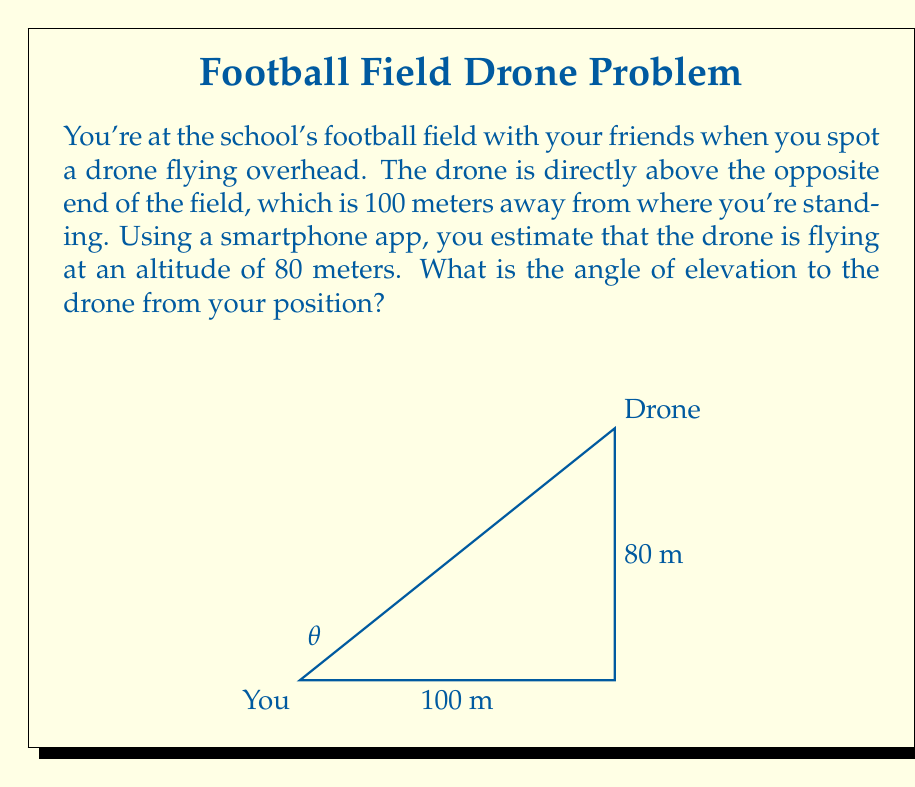Give your solution to this math problem. Let's approach this step-by-step using trigonometry:

1) We can identify this as a right triangle problem. The angle of elevation is the angle between the horizontal line of sight and the line of sight to the drone.

2) We know:
   - The adjacent side (distance along the ground) = 100 meters
   - The opposite side (height of the drone) = 80 meters

3) To find the angle, we can use the tangent function:

   $$ \tan(\theta) = \frac{\text{opposite}}{\text{adjacent}} $$

4) Plugging in our values:

   $$ \tan(\theta) = \frac{80}{100} = 0.8 $$

5) To find $\theta$, we need to use the inverse tangent (arctan or $\tan^{-1}$):

   $$ \theta = \tan^{-1}(0.8) $$

6) Using a calculator or trigonometric tables:

   $$ \theta \approx 38.66^\circ $$

Therefore, the angle of elevation to the drone is approximately 38.66°.
Answer: $38.66^\circ$ 